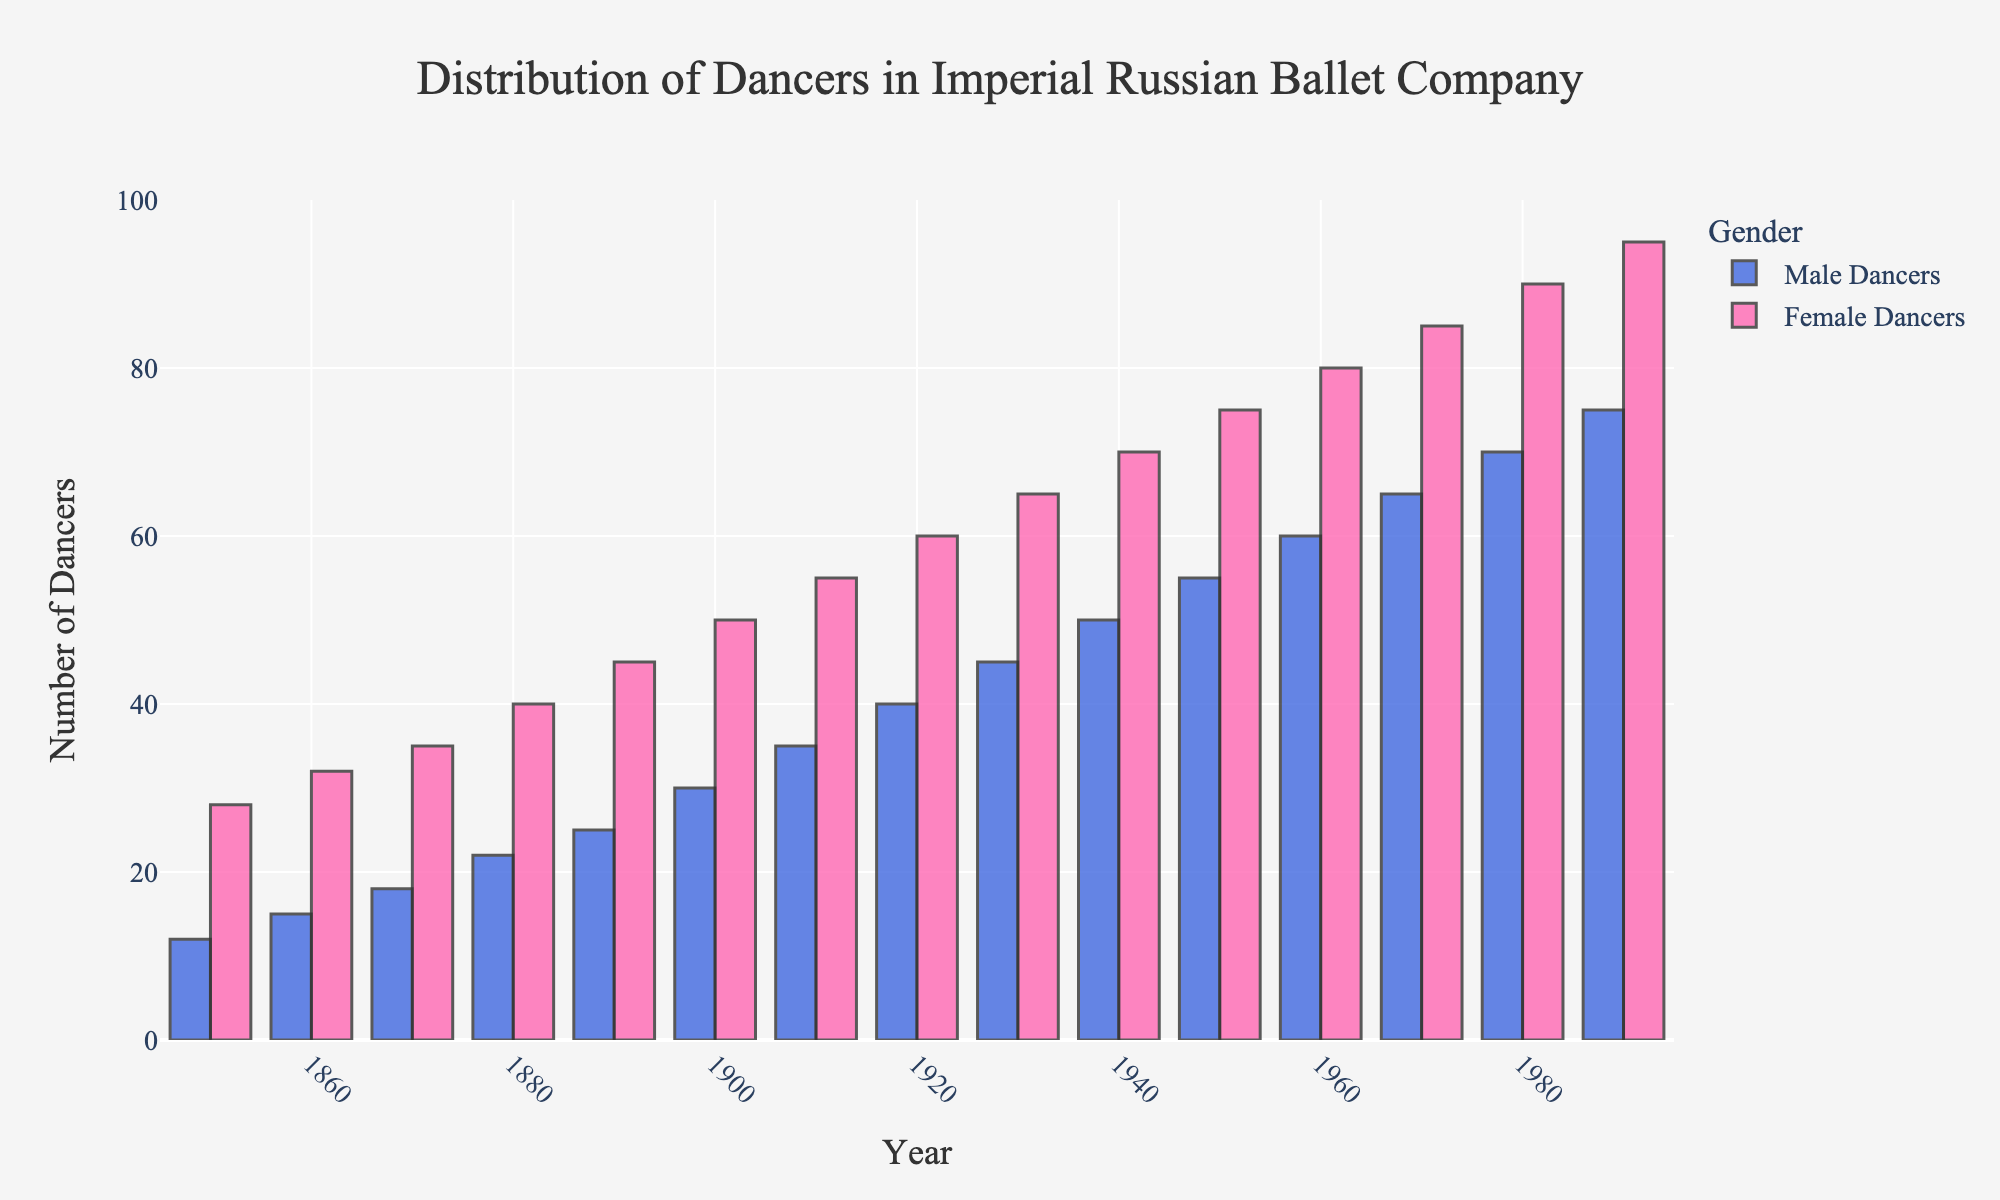How many more female dancers were there than male dancers in 1910? In 1910, the plot shows 35 male dancers and 55 female dancers. The difference between the number of female and male dancers is 55 - 35.
Answer: 20 What is the ratio of female to male dancers in 1940? In 1940, there are 50 male dancers and 70 female dancers. The ratio of females to males is 70:50, which simplifies to 7:5.
Answer: 7:5 In which year did the number of male dancers first reach 30? By examining the bar representing male dancers over the years, the number of 30 male dancers first appeared in the year 1900.
Answer: 1900 Compare the increase in the number of female dancers from 1850 to 1900 to that from 1900 to 1950. From 1850 to 1900, the number of female dancers increased from 28 to 50, a rise of 22 dancers (50 - 28). From 1900 to 1950, the number of female dancers increased from 50 to 75, a rise of 25 dancers (75 - 50).
Answer: From 1900 to 1950 What's the average number of male dancers in the years 1850, 1870, 1890, and 1910? Sum the number of male dancers in these years: 12 (1850) + 18 (1870) + 25 (1890) + 35 (1910) = 90. The average is 90 / 4.
Answer: 22.5 Was there any year when the number of male dancers equaled the number of female dancers? Observing the plot, the bars representing male and female dancers are never of equal height in any of the years shown.
Answer: No Which year saw the highest number of dancers joining the company when combining both male and female dancers? Calculate the combined number of dancers each year; the year with the highest sum (male + female) represents the peak. Inspecting the tallest combined bars, in 1990, the total dancers are 75 (male) + 95 (female) = 170.
Answer: 1990 Identify the decade with the largest increase in the total number of dancers. Calculate the total dancers at the start and end of each decade. The largest difference indicates the decade with the largest increase. Peak increase is between 1920 (100) and 1930 (110), leading to a difference of +10.
Answer: 1920-1930 How do the heights of bars for male and female dancers in the 1980's compare visually? In 1980, the height of the bar for male dancers (70) is consistently shorter than that for female dancers (90), showing a balanced ratio across years but still consistently higher for females.
Answer: Female dancers' bar was taller In the early years shown, were females always more than twice the number of male dancers? Compare the numbers directly for early years 1850, 1860, 1870, noting values and calculating twice the males. E.g., 1850 had 28 females vs. twice 12 males (24), etc.
Answer: Yes 